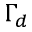<formula> <loc_0><loc_0><loc_500><loc_500>\Gamma _ { d }</formula> 